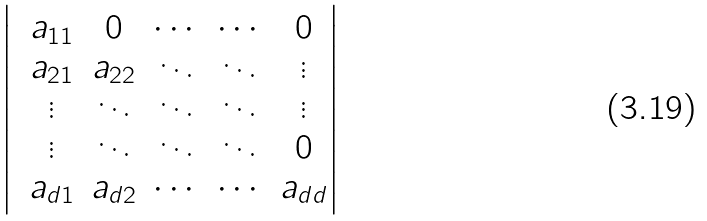Convert formula to latex. <formula><loc_0><loc_0><loc_500><loc_500>\begin{vmatrix} & a _ { 1 1 } & 0 & \cdots & \cdots & 0 \\ & a _ { 2 1 } & a _ { 2 2 } & \ddots & \ddots & \vdots \\ & \vdots & \ddots & \ddots & \ddots & \vdots \\ & \vdots & \ddots & \ddots & \ddots & 0 \\ & a _ { d 1 } & a _ { d 2 } & \cdots & \cdots & a _ { d d } \end{vmatrix}</formula> 